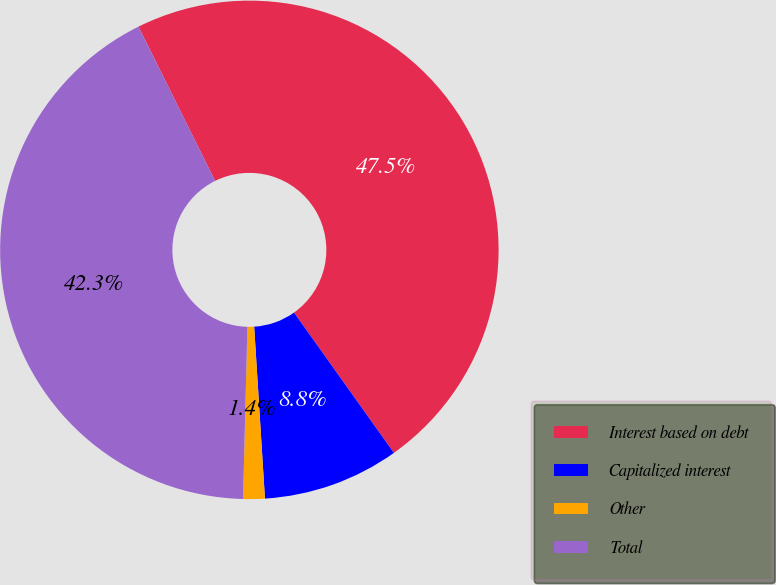Convert chart to OTSL. <chart><loc_0><loc_0><loc_500><loc_500><pie_chart><fcel>Interest based on debt<fcel>Capitalized interest<fcel>Other<fcel>Total<nl><fcel>47.5%<fcel>8.85%<fcel>1.4%<fcel>42.26%<nl></chart> 